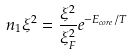Convert formula to latex. <formula><loc_0><loc_0><loc_500><loc_500>n _ { 1 } \xi ^ { 2 } = \frac { \xi ^ { 2 } } { \xi _ { F } ^ { 2 } } e ^ { - E _ { c o r e } / T }</formula> 